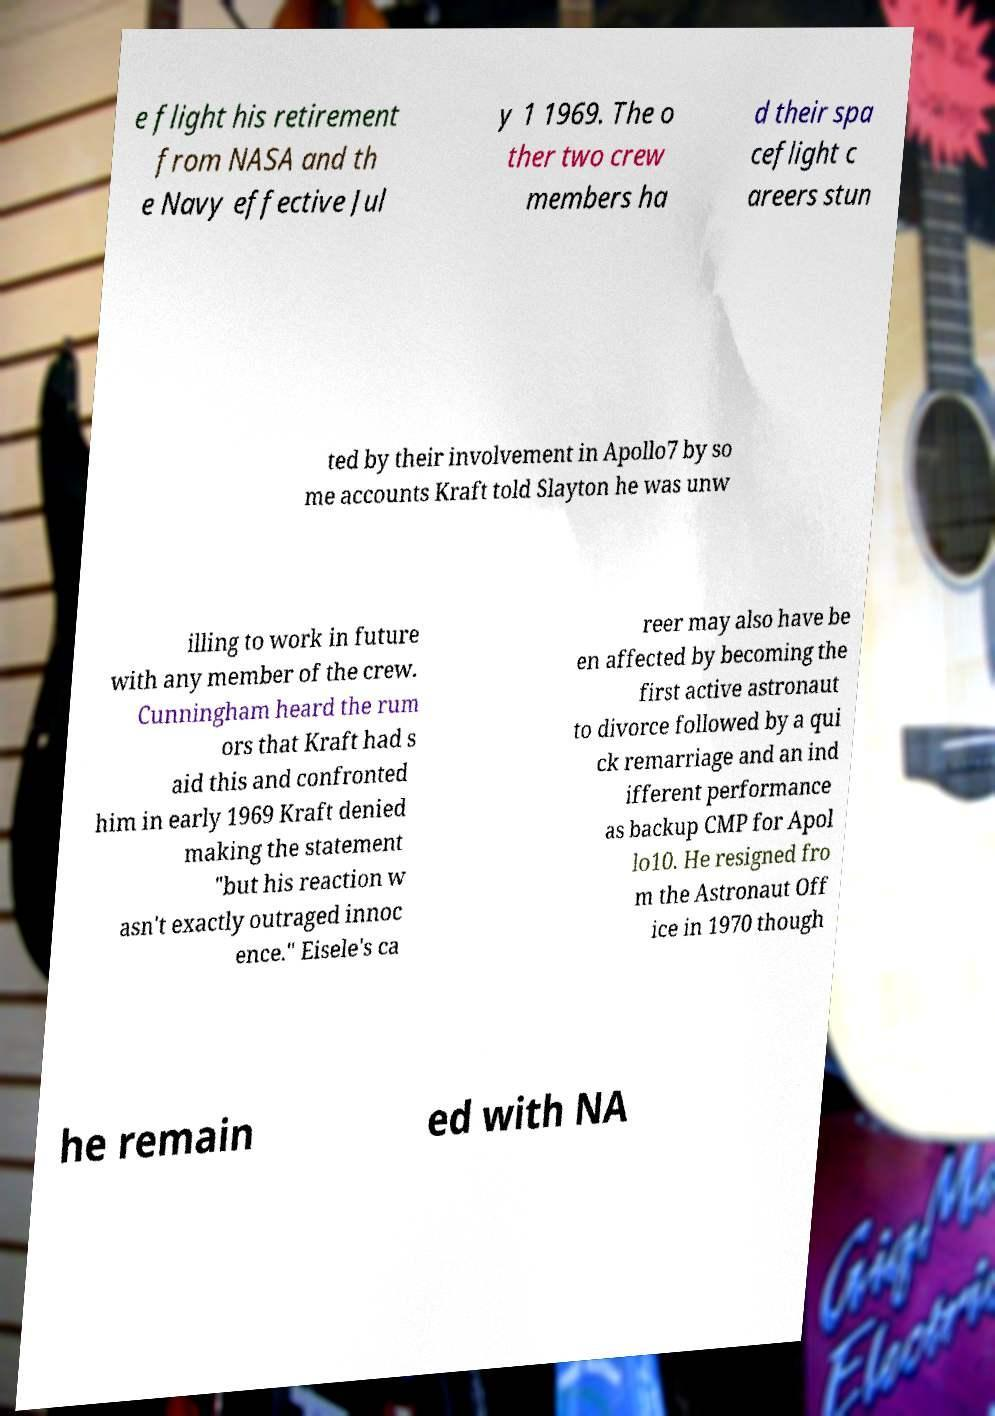I need the written content from this picture converted into text. Can you do that? e flight his retirement from NASA and th e Navy effective Jul y 1 1969. The o ther two crew members ha d their spa ceflight c areers stun ted by their involvement in Apollo7 by so me accounts Kraft told Slayton he was unw illing to work in future with any member of the crew. Cunningham heard the rum ors that Kraft had s aid this and confronted him in early 1969 Kraft denied making the statement "but his reaction w asn't exactly outraged innoc ence." Eisele's ca reer may also have be en affected by becoming the first active astronaut to divorce followed by a qui ck remarriage and an ind ifferent performance as backup CMP for Apol lo10. He resigned fro m the Astronaut Off ice in 1970 though he remain ed with NA 